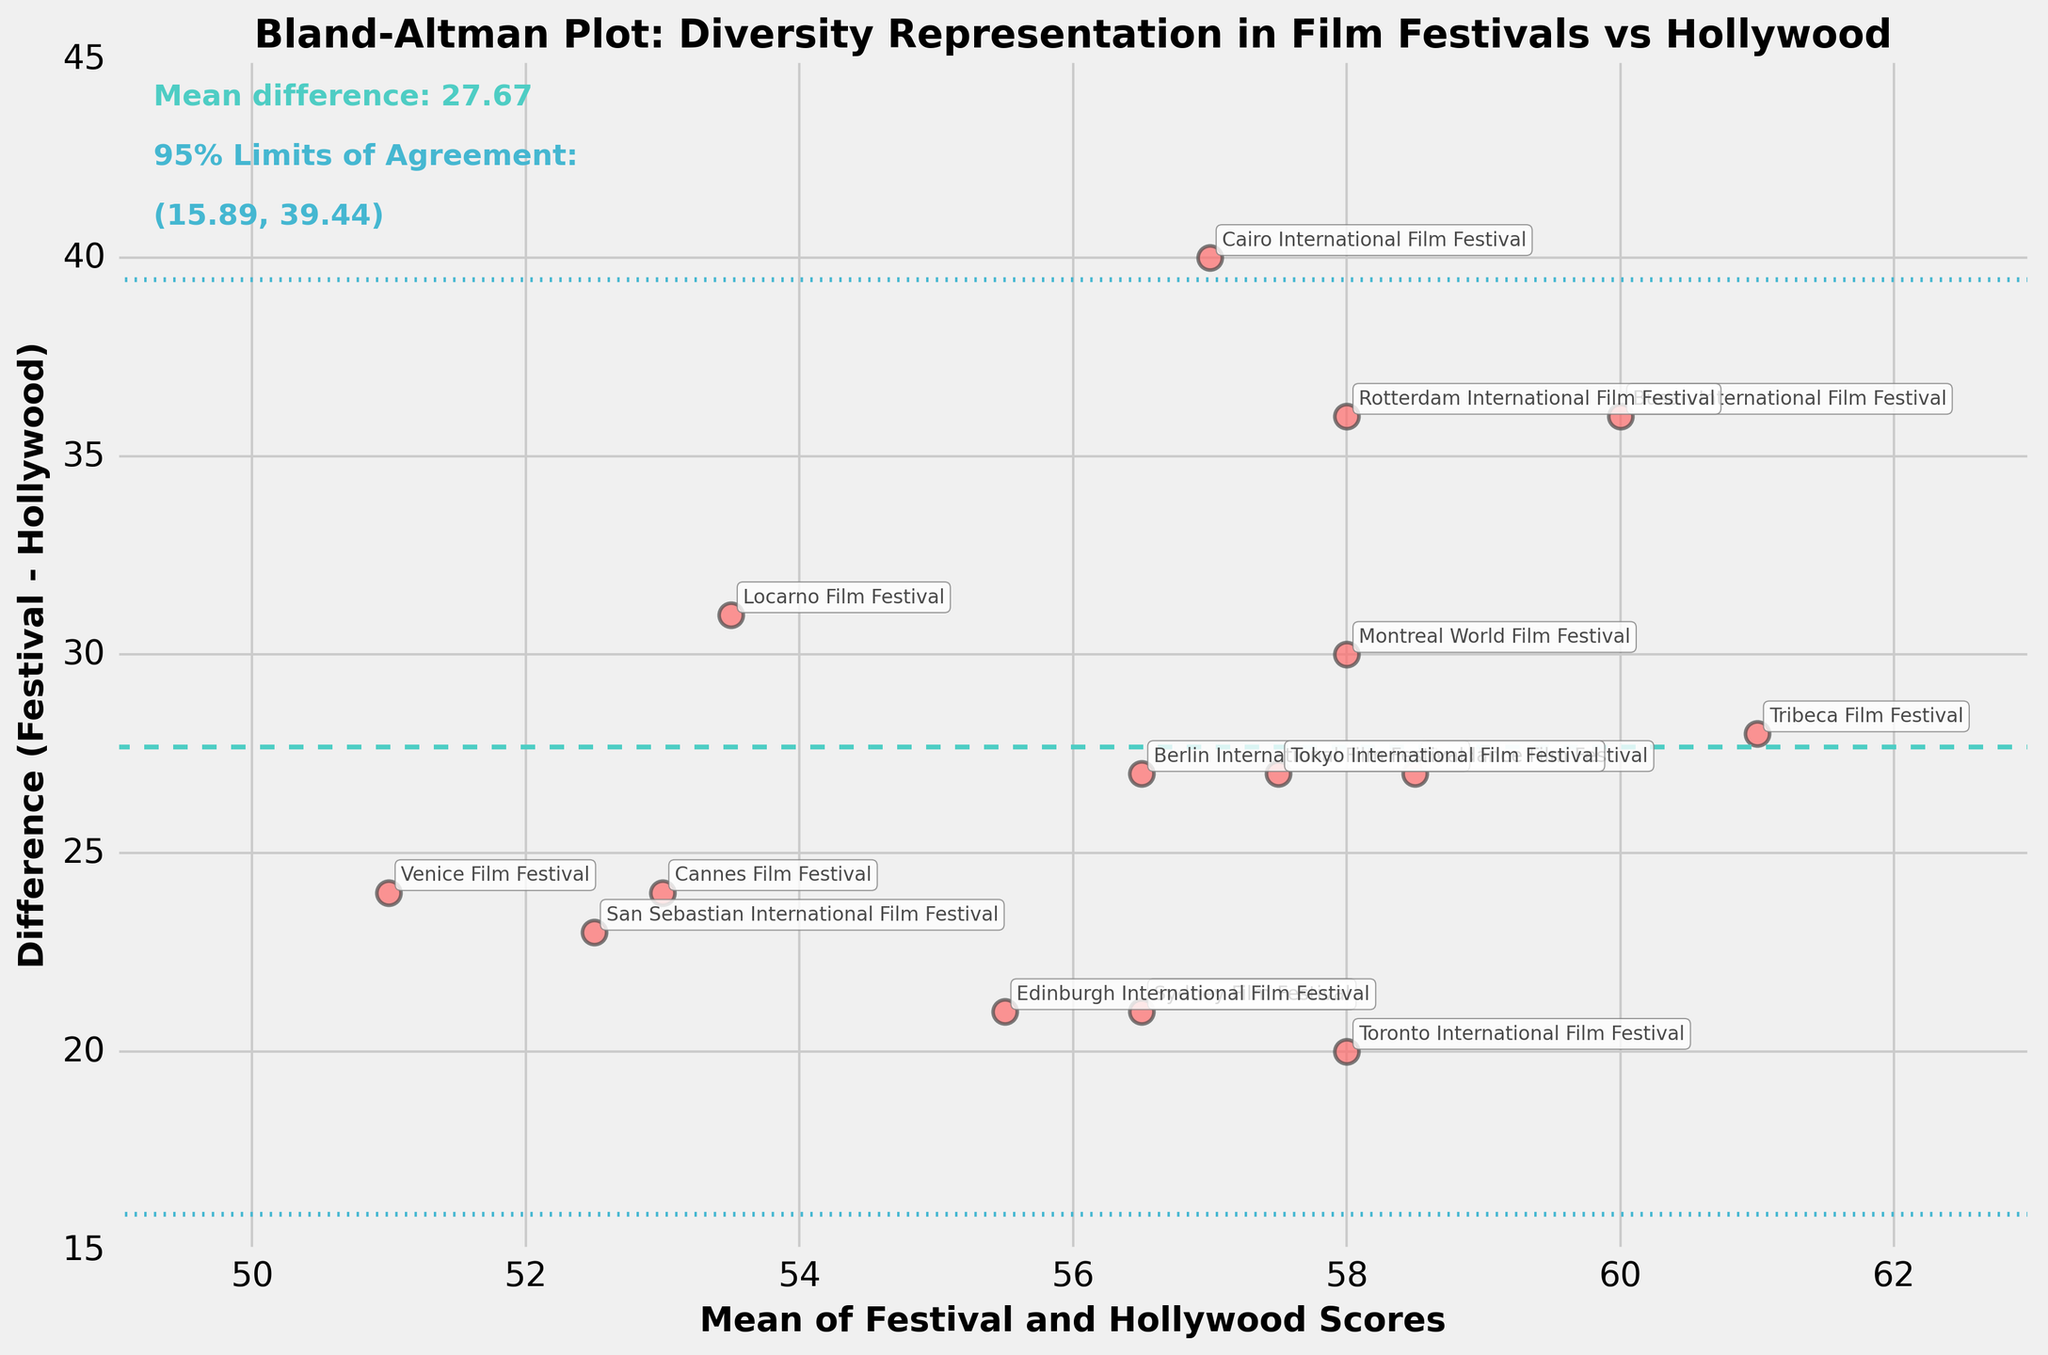How many data points are represented in the plot? Count the individual points plotted on the figure. There are 15 film festivals listed, and each one is represented by a single point, so there are 15 data points.
Answer: 15 What are the x and y axes representing in the plot? Identify the labels on the x and y axes. The x-axis represents the "Mean of Festival and Hollywood Scores," and the y-axis represents "Difference (Festival - Hollywood)."
Answer: Mean Scores and Difference Which film festival has the largest difference in diversity score compared to Hollywood? Observe the y-axis values to find the point with the largest positive y-value. The Busan International Film Festival has the largest difference with a score difference of 36.
Answer: Busan International Film Festival What are the 95% limits of agreement in this plot? Read the annotated text within the figure. The limits of agreement are (14.43, 33.77).
Answer: 14.43 and 33.77 What is the mean difference in diversity scores between film festivals and Hollywood? Read the annotated text within the figure. The mean difference is 24.10.
Answer: 24.10 What are the mean diversity scores for the Toronto International Film Festival and Hollywood? Locate the annotated point for the Toronto International Film Festival and find its x-coordinate. The mean score is approximately 58.0.
Answer: 58.0 Are there any film festivals with a negative difference in diversity score compared to Hollywood? Check the y-axis values to see if any points have negative values. All points appear to have positive differences, indicating no negative differences.
Answer: No Which film festival has a mean score closest to 50? Locate the point nearest to the x-axis value of 50. The Cairo International Film Festival has a mean score close to 50.
Answer: Cairo International Film Festival Can you identify which film festival has an exact mean difference of 25? Identify the point on the y-axis where the difference is 25 and read the annotation. The Berlin International Film Festival shows a difference of exactly 25.
Answer: Berlin International Film Festival What is the upper limit of the agreement range indicating? Interpret the position of the upper horizontal dotted line. It indicates the boundary above which the difference in diversity scores is considered significantly different, specifically 33.77.
Answer: 33.77 